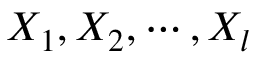<formula> <loc_0><loc_0><loc_500><loc_500>X _ { 1 } , X _ { 2 } , \cdots , X _ { l }</formula> 